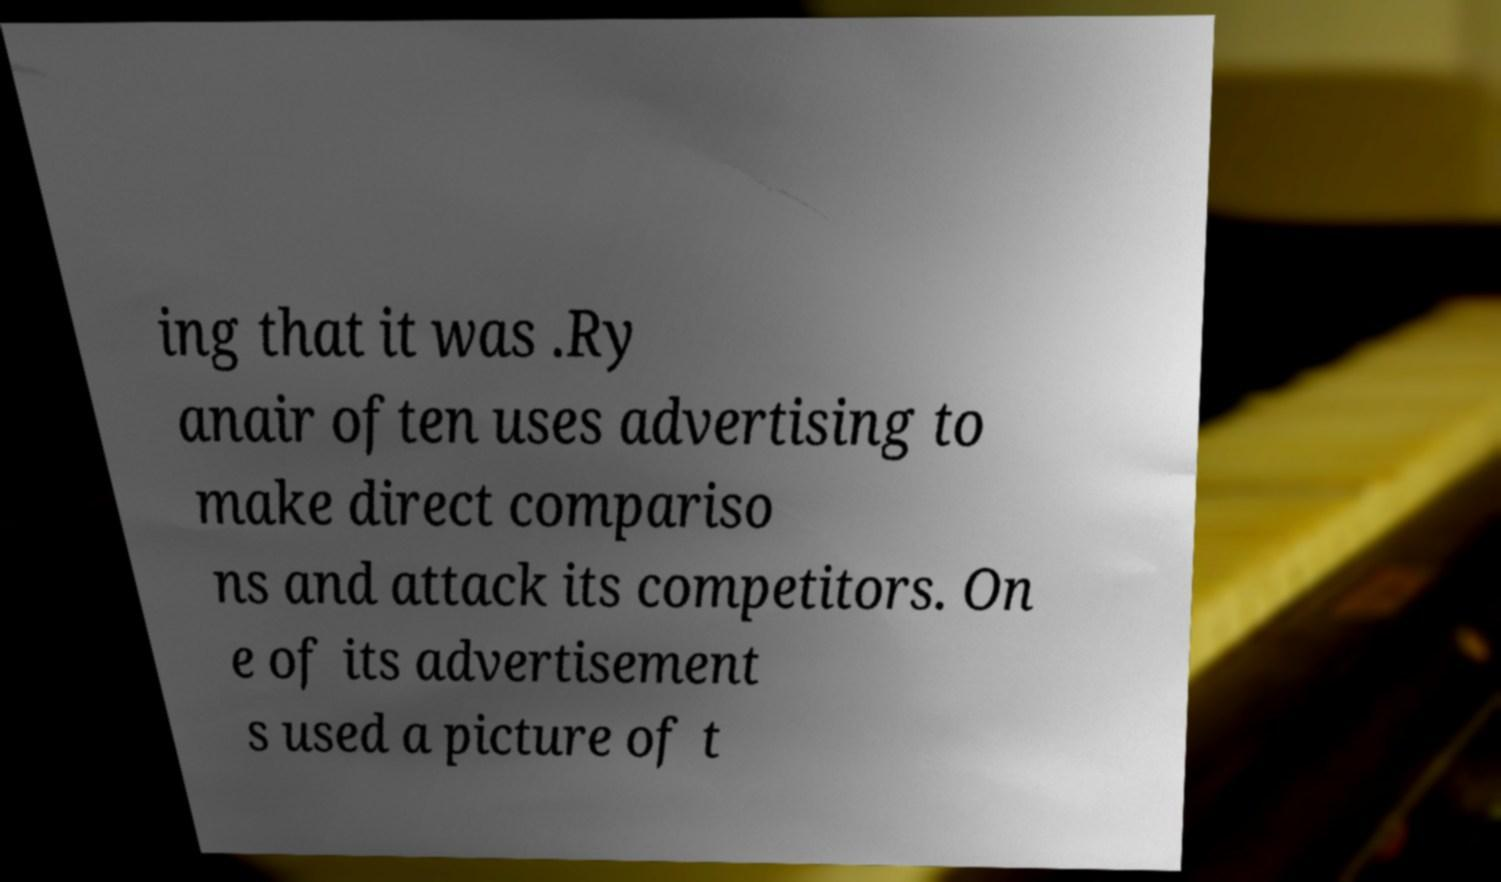Could you extract and type out the text from this image? ing that it was .Ry anair often uses advertising to make direct compariso ns and attack its competitors. On e of its advertisement s used a picture of t 